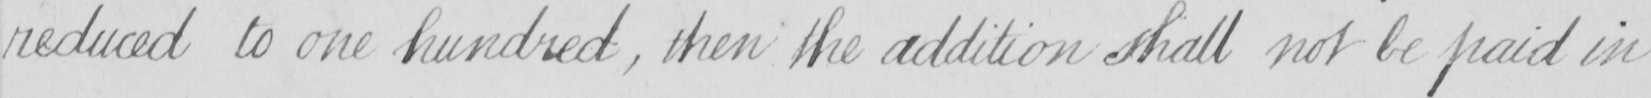What text is written in this handwritten line? reduced to one hundred , then the addition shall not be paid in 